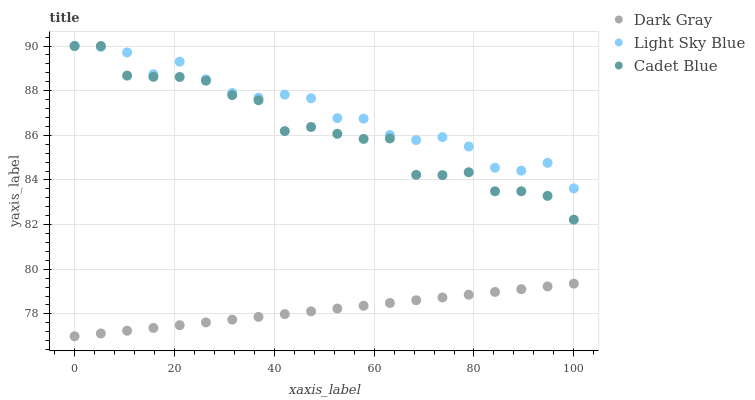Does Dark Gray have the minimum area under the curve?
Answer yes or no. Yes. Does Light Sky Blue have the maximum area under the curve?
Answer yes or no. Yes. Does Cadet Blue have the minimum area under the curve?
Answer yes or no. No. Does Cadet Blue have the maximum area under the curve?
Answer yes or no. No. Is Dark Gray the smoothest?
Answer yes or no. Yes. Is Cadet Blue the roughest?
Answer yes or no. Yes. Is Light Sky Blue the smoothest?
Answer yes or no. No. Is Light Sky Blue the roughest?
Answer yes or no. No. Does Dark Gray have the lowest value?
Answer yes or no. Yes. Does Cadet Blue have the lowest value?
Answer yes or no. No. Does Cadet Blue have the highest value?
Answer yes or no. Yes. Is Dark Gray less than Cadet Blue?
Answer yes or no. Yes. Is Light Sky Blue greater than Dark Gray?
Answer yes or no. Yes. Does Cadet Blue intersect Light Sky Blue?
Answer yes or no. Yes. Is Cadet Blue less than Light Sky Blue?
Answer yes or no. No. Is Cadet Blue greater than Light Sky Blue?
Answer yes or no. No. Does Dark Gray intersect Cadet Blue?
Answer yes or no. No. 